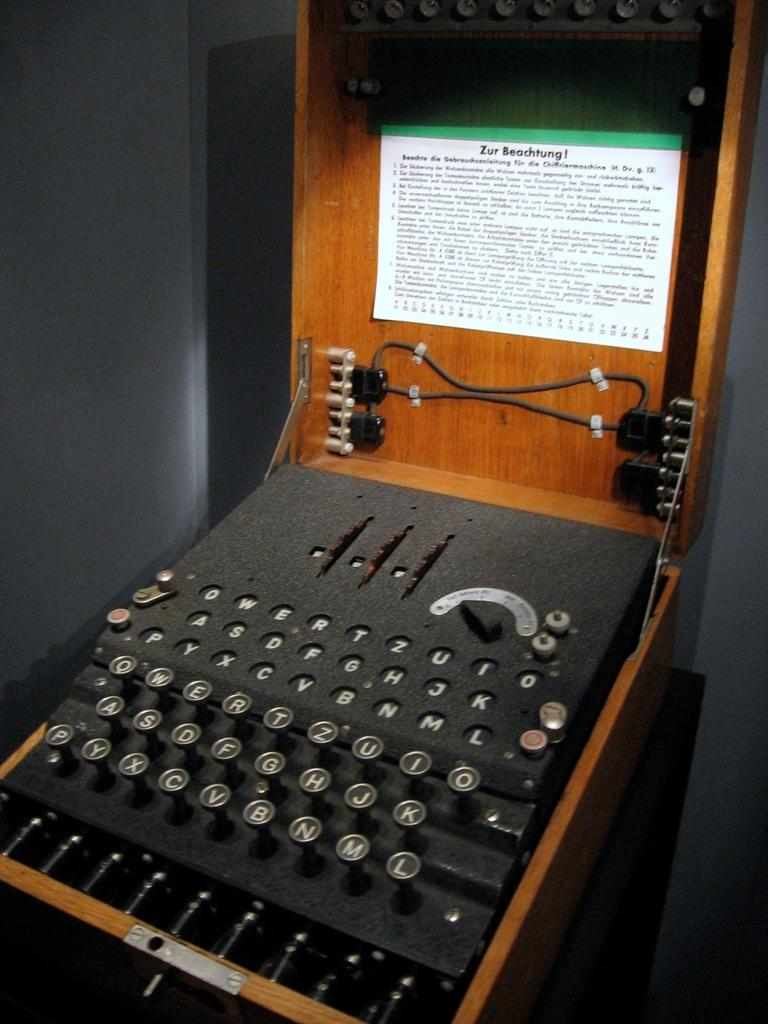<image>
Render a clear and concise summary of the photo. A very old typewriter machine includes a sign that says Zur Beachtung! 